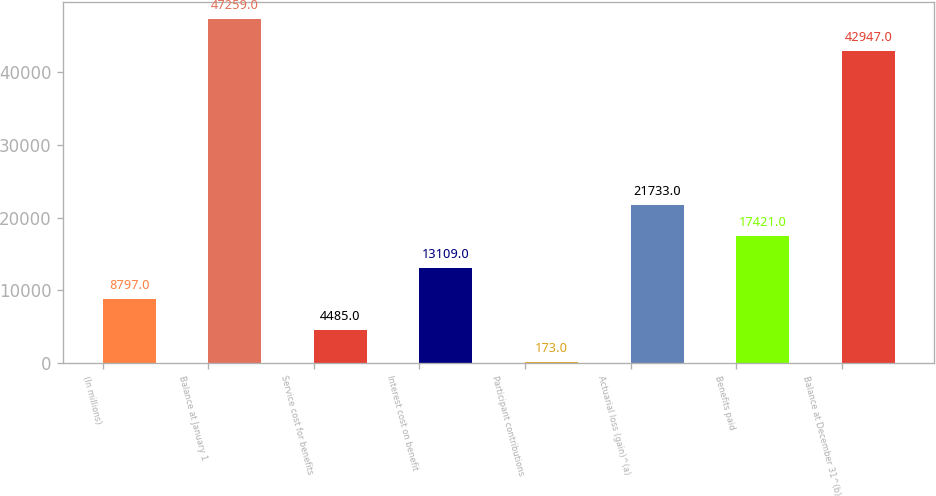Convert chart to OTSL. <chart><loc_0><loc_0><loc_500><loc_500><bar_chart><fcel>(In millions)<fcel>Balance at January 1<fcel>Service cost for benefits<fcel>Interest cost on benefit<fcel>Participant contributions<fcel>Actuarial loss (gain)^(a)<fcel>Benefits paid<fcel>Balance at December 31^(b)<nl><fcel>8797<fcel>47259<fcel>4485<fcel>13109<fcel>173<fcel>21733<fcel>17421<fcel>42947<nl></chart> 